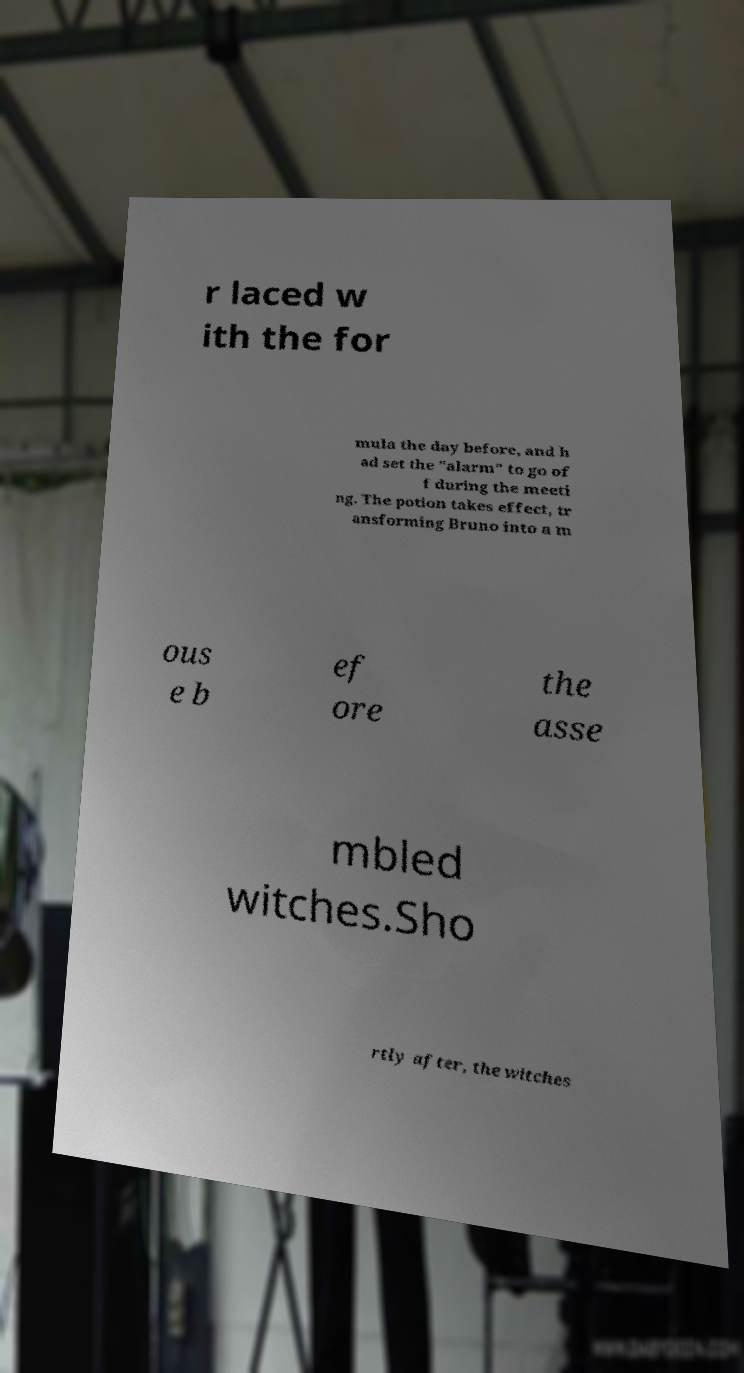For documentation purposes, I need the text within this image transcribed. Could you provide that? r laced w ith the for mula the day before, and h ad set the "alarm" to go of f during the meeti ng. The potion takes effect, tr ansforming Bruno into a m ous e b ef ore the asse mbled witches.Sho rtly after, the witches 